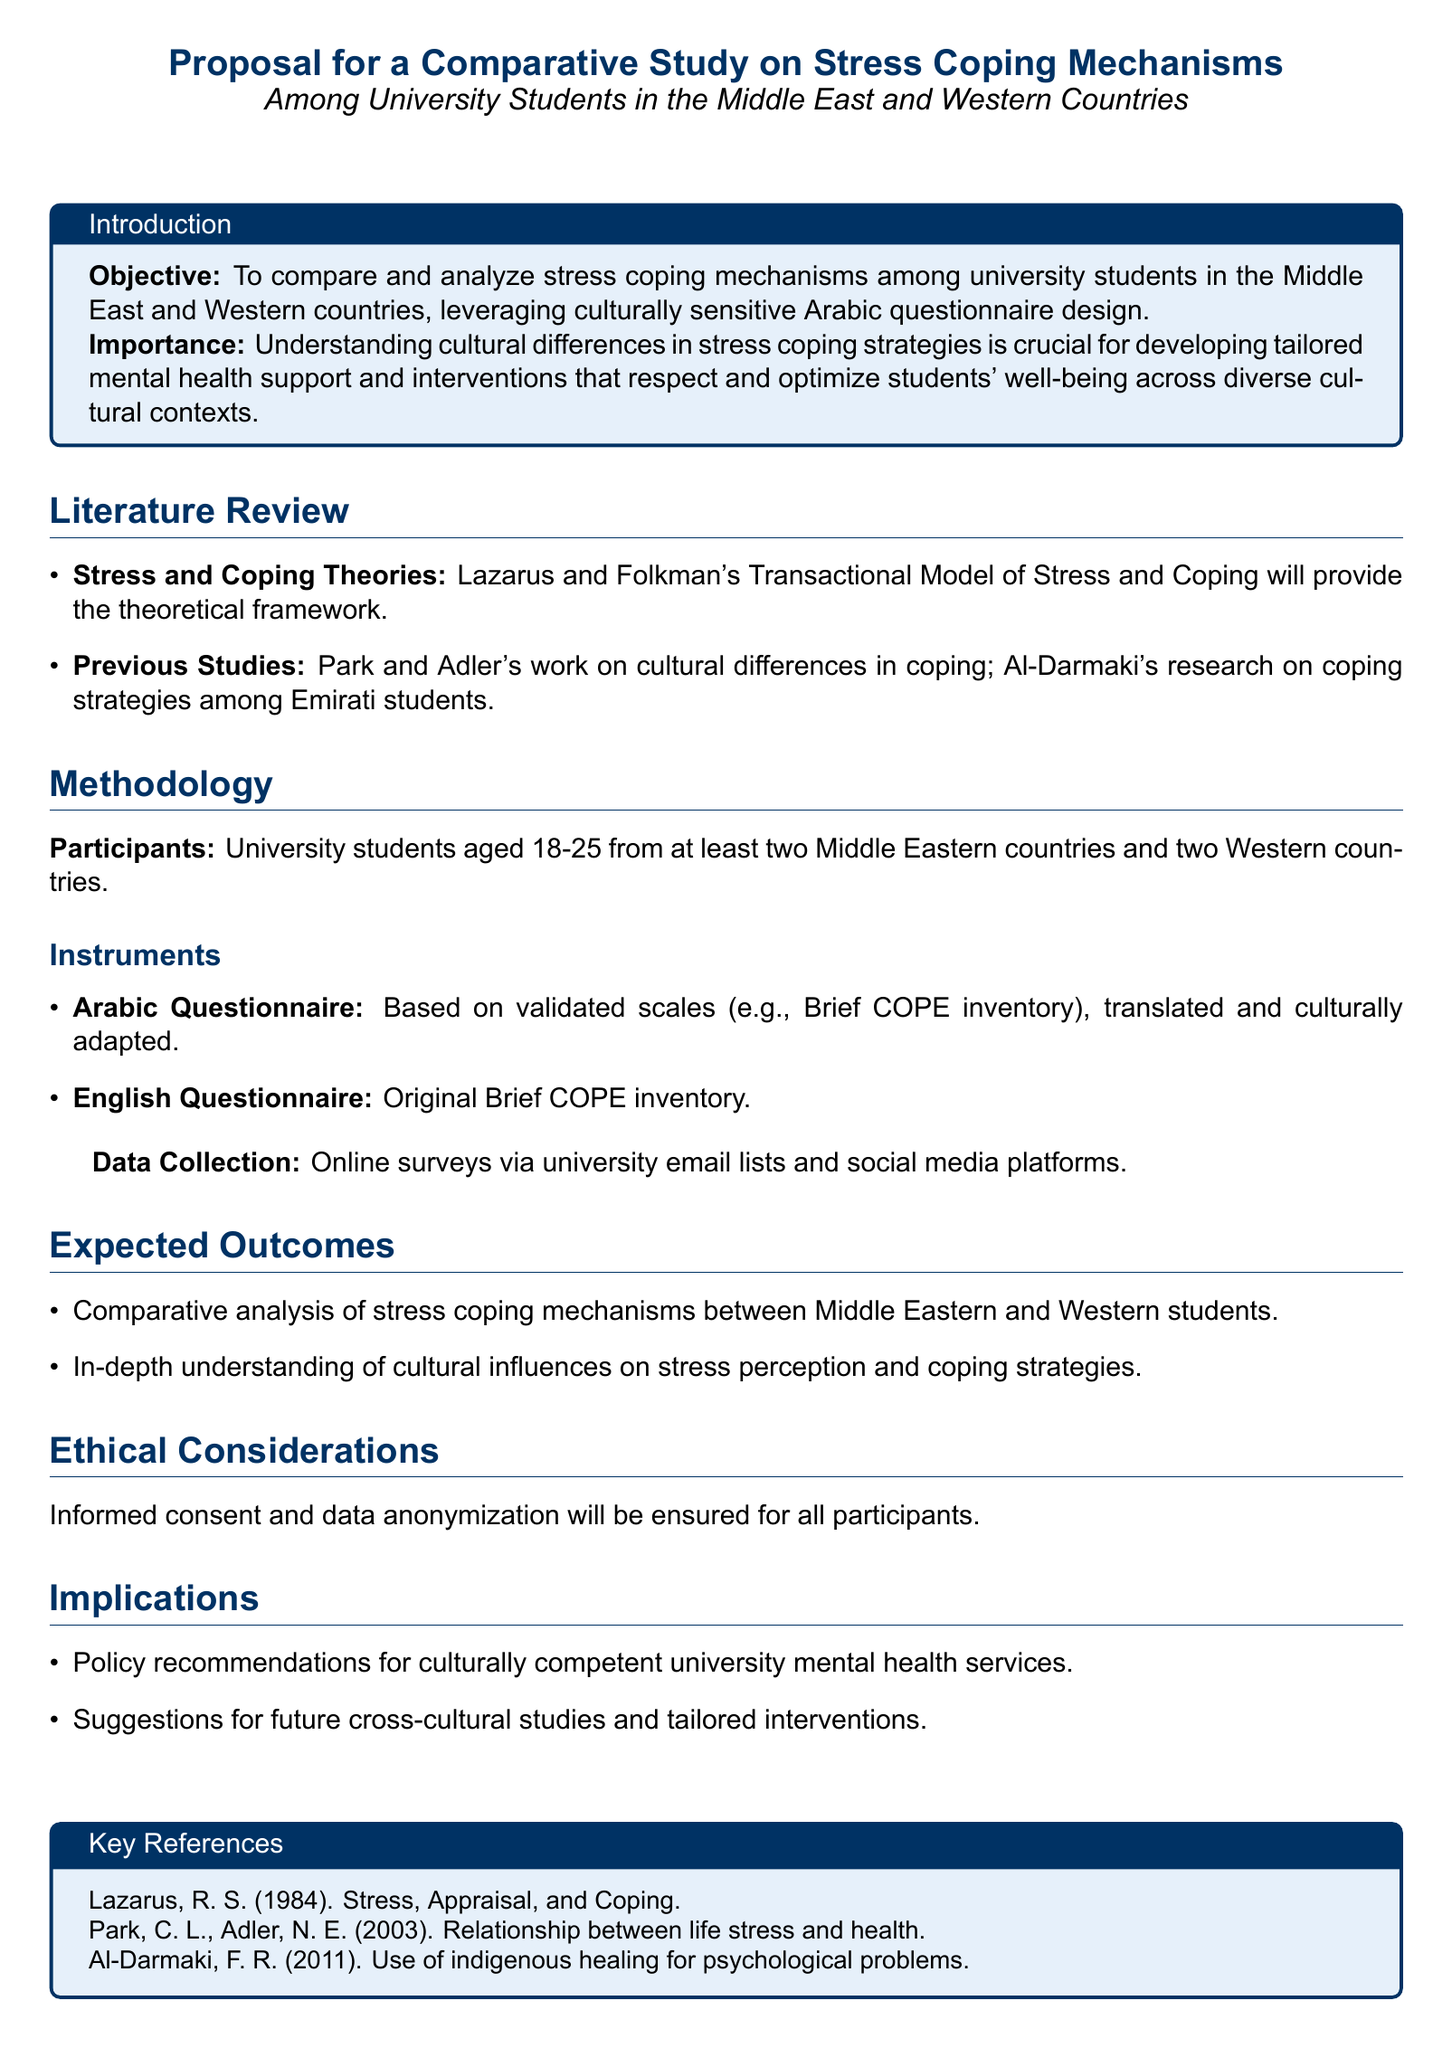what is the objective of the study? The objective is to compare and analyze stress coping mechanisms among university students in the Middle East and Western countries.
Answer: to compare and analyze stress coping mechanisms who are the participants in the study? The participants are university students aged 18-25.
Answer: university students aged 18-25 which questionnaire is culturally adapted for the Arabic version? The Arabic questionnaire is based on validated scales such as the Brief COPE inventory.
Answer: Brief COPE inventory what is the theoretical framework used in the study? The theoretical framework is Lazarus and Folkman's Transactional Model of Stress and Coping.
Answer: Transactional Model of Stress and Coping what is a key ethical consideration mentioned in the proposal? The proposal mentions informed consent and data anonymization.
Answer: informed consent and data anonymization which countries are included for comparison in the study? The study includes at least two Middle Eastern countries and two Western countries.
Answer: two Middle Eastern countries and two Western countries what type of analysis is expected as an outcome? A comparative analysis of stress coping mechanisms is expected.
Answer: comparative analysis of stress coping mechanisms who conducted research on coping strategies among Emirati students? Research on coping strategies among Emirati students was conducted by Al-Darmaki.
Answer: Al-Darmaki what will the findings influence according to the proposal? The findings will influence policy recommendations for culturally competent university mental health services.
Answer: policy recommendations for culturally competent university mental health services 